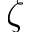<formula> <loc_0><loc_0><loc_500><loc_500>\zeta</formula> 